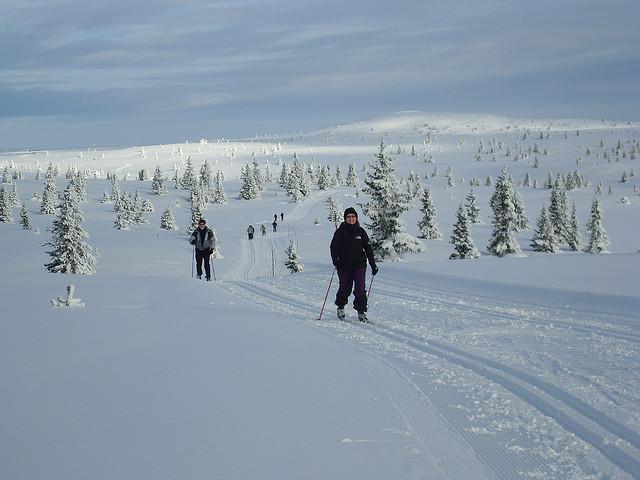Are there any signs of civilization in sight?
Quick response, please. No. How many green coats are being worn?
Answer briefly. 0. Is this a Christmas tree farm?
Short answer required. No. What are the objects surrounding the people?
Short answer required. Trees. 